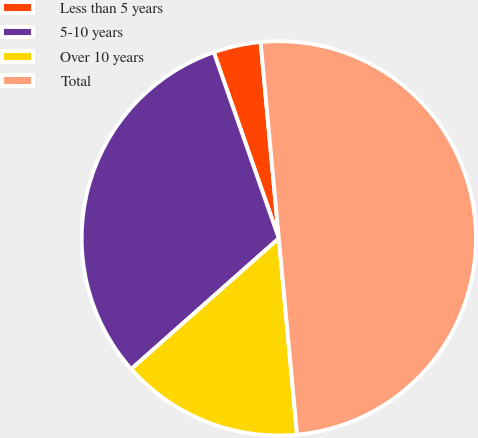Convert chart to OTSL. <chart><loc_0><loc_0><loc_500><loc_500><pie_chart><fcel>Less than 5 years<fcel>5-10 years<fcel>Over 10 years<fcel>Total<nl><fcel>3.88%<fcel>31.19%<fcel>14.94%<fcel>50.0%<nl></chart> 